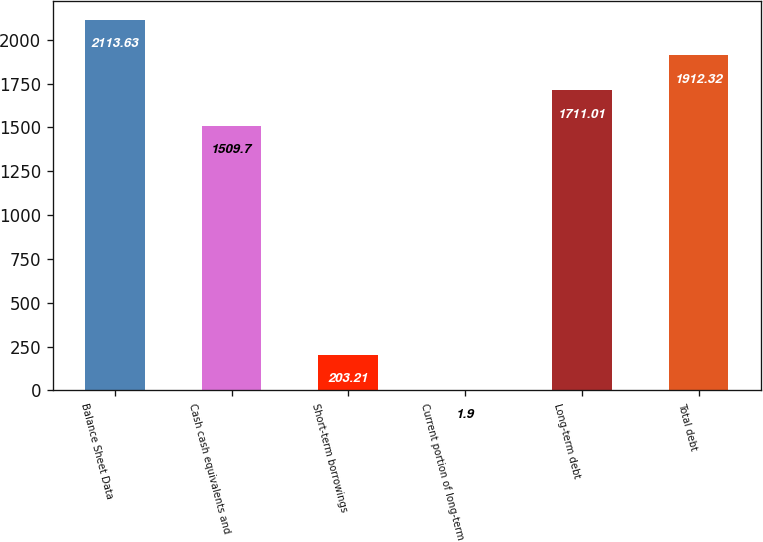<chart> <loc_0><loc_0><loc_500><loc_500><bar_chart><fcel>Balance Sheet Data<fcel>Cash cash equivalents and<fcel>Short-term borrowings<fcel>Current portion of long-term<fcel>Long-term debt<fcel>Total debt<nl><fcel>2113.63<fcel>1509.7<fcel>203.21<fcel>1.9<fcel>1711.01<fcel>1912.32<nl></chart> 